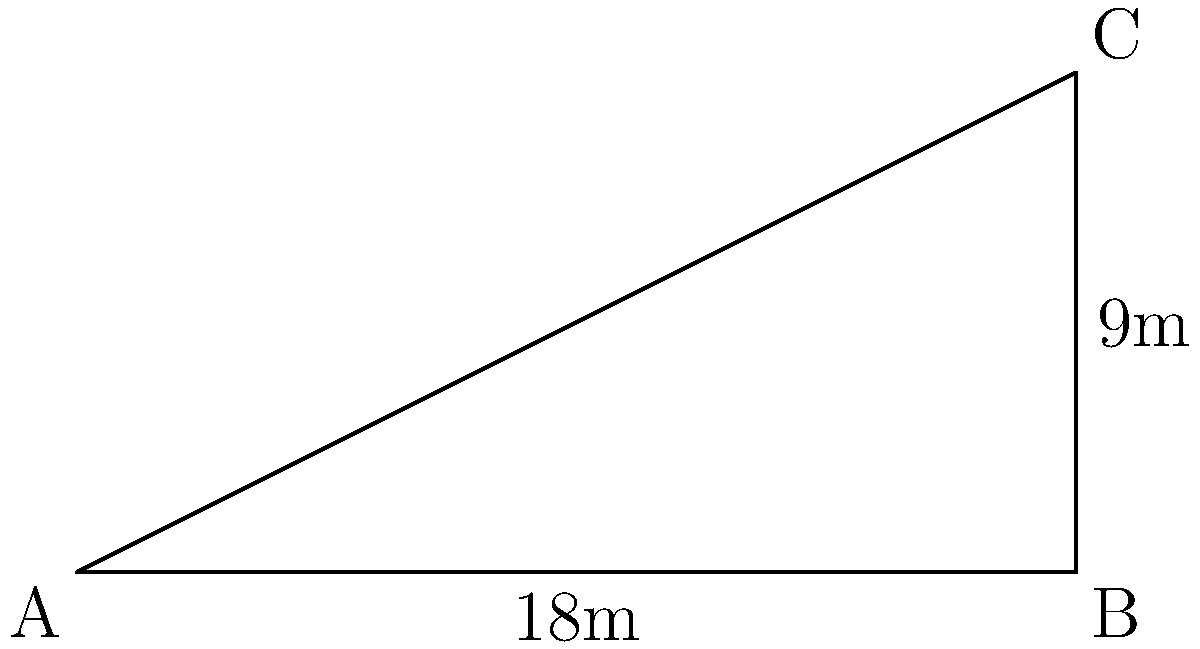While filming Prague Castle, you notice the distinct sloped roofs. To capture the perfect angle, you need to determine the angle of inclination. From your vantage point, you measure the horizontal distance of the roof as 18 meters and its vertical height as 9 meters. Using these measurements, calculate the angle of inclination of the roof. To solve this problem, we'll use basic trigonometry:

1) We have a right triangle where:
   - The base (adjacent side) is 18 meters
   - The height (opposite side) is 9 meters
   - We need to find the angle of inclination (let's call it θ)

2) In a right triangle, tangent of an angle is the ratio of the opposite side to the adjacent side:

   $$\tan(\theta) = \frac{\text{opposite}}{\text{adjacent}}$$

3) Plugging in our values:

   $$\tan(\theta) = \frac{9}{18} = \frac{1}{2}$$

4) To find θ, we need to take the inverse tangent (arctan or tan^(-1)) of both sides:

   $$\theta = \tan^{-1}(\frac{1}{2})$$

5) Using a calculator or trigonometric tables:

   $$\theta \approx 26.57°$$

Therefore, the angle of inclination of the roof is approximately 26.57 degrees.
Answer: 26.57° 